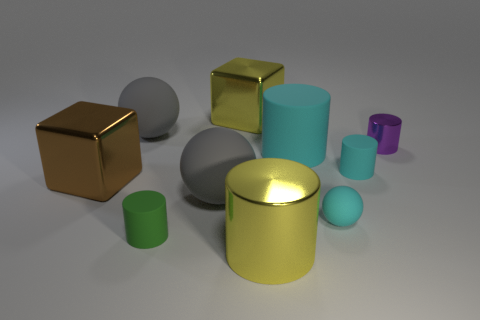There is a cyan cylinder that is on the right side of the cyan sphere; is its size the same as the tiny sphere?
Keep it short and to the point. Yes. Are there more gray matte things that are in front of the purple cylinder than blue objects?
Make the answer very short. Yes. How many small green cylinders are on the right side of the metal cylinder behind the big yellow cylinder?
Give a very brief answer. 0. Is the number of cyan things that are in front of the large cyan rubber thing less than the number of shiny balls?
Your answer should be compact. No. There is a gray rubber ball right of the tiny cylinder that is in front of the small sphere; is there a large thing on the right side of it?
Your response must be concise. Yes. Do the large brown object and the small cylinder that is left of the yellow metallic cylinder have the same material?
Ensure brevity in your answer.  No. There is a large rubber sphere that is in front of the big gray matte sphere behind the big brown metal block; what is its color?
Make the answer very short. Gray. Is there a small rubber cylinder that has the same color as the tiny sphere?
Give a very brief answer. Yes. There is a yellow object to the left of the large cylinder in front of the cylinder that is left of the yellow shiny cylinder; what is its size?
Make the answer very short. Large. Does the large brown thing have the same shape as the big yellow shiny object behind the large brown metal thing?
Make the answer very short. Yes. 